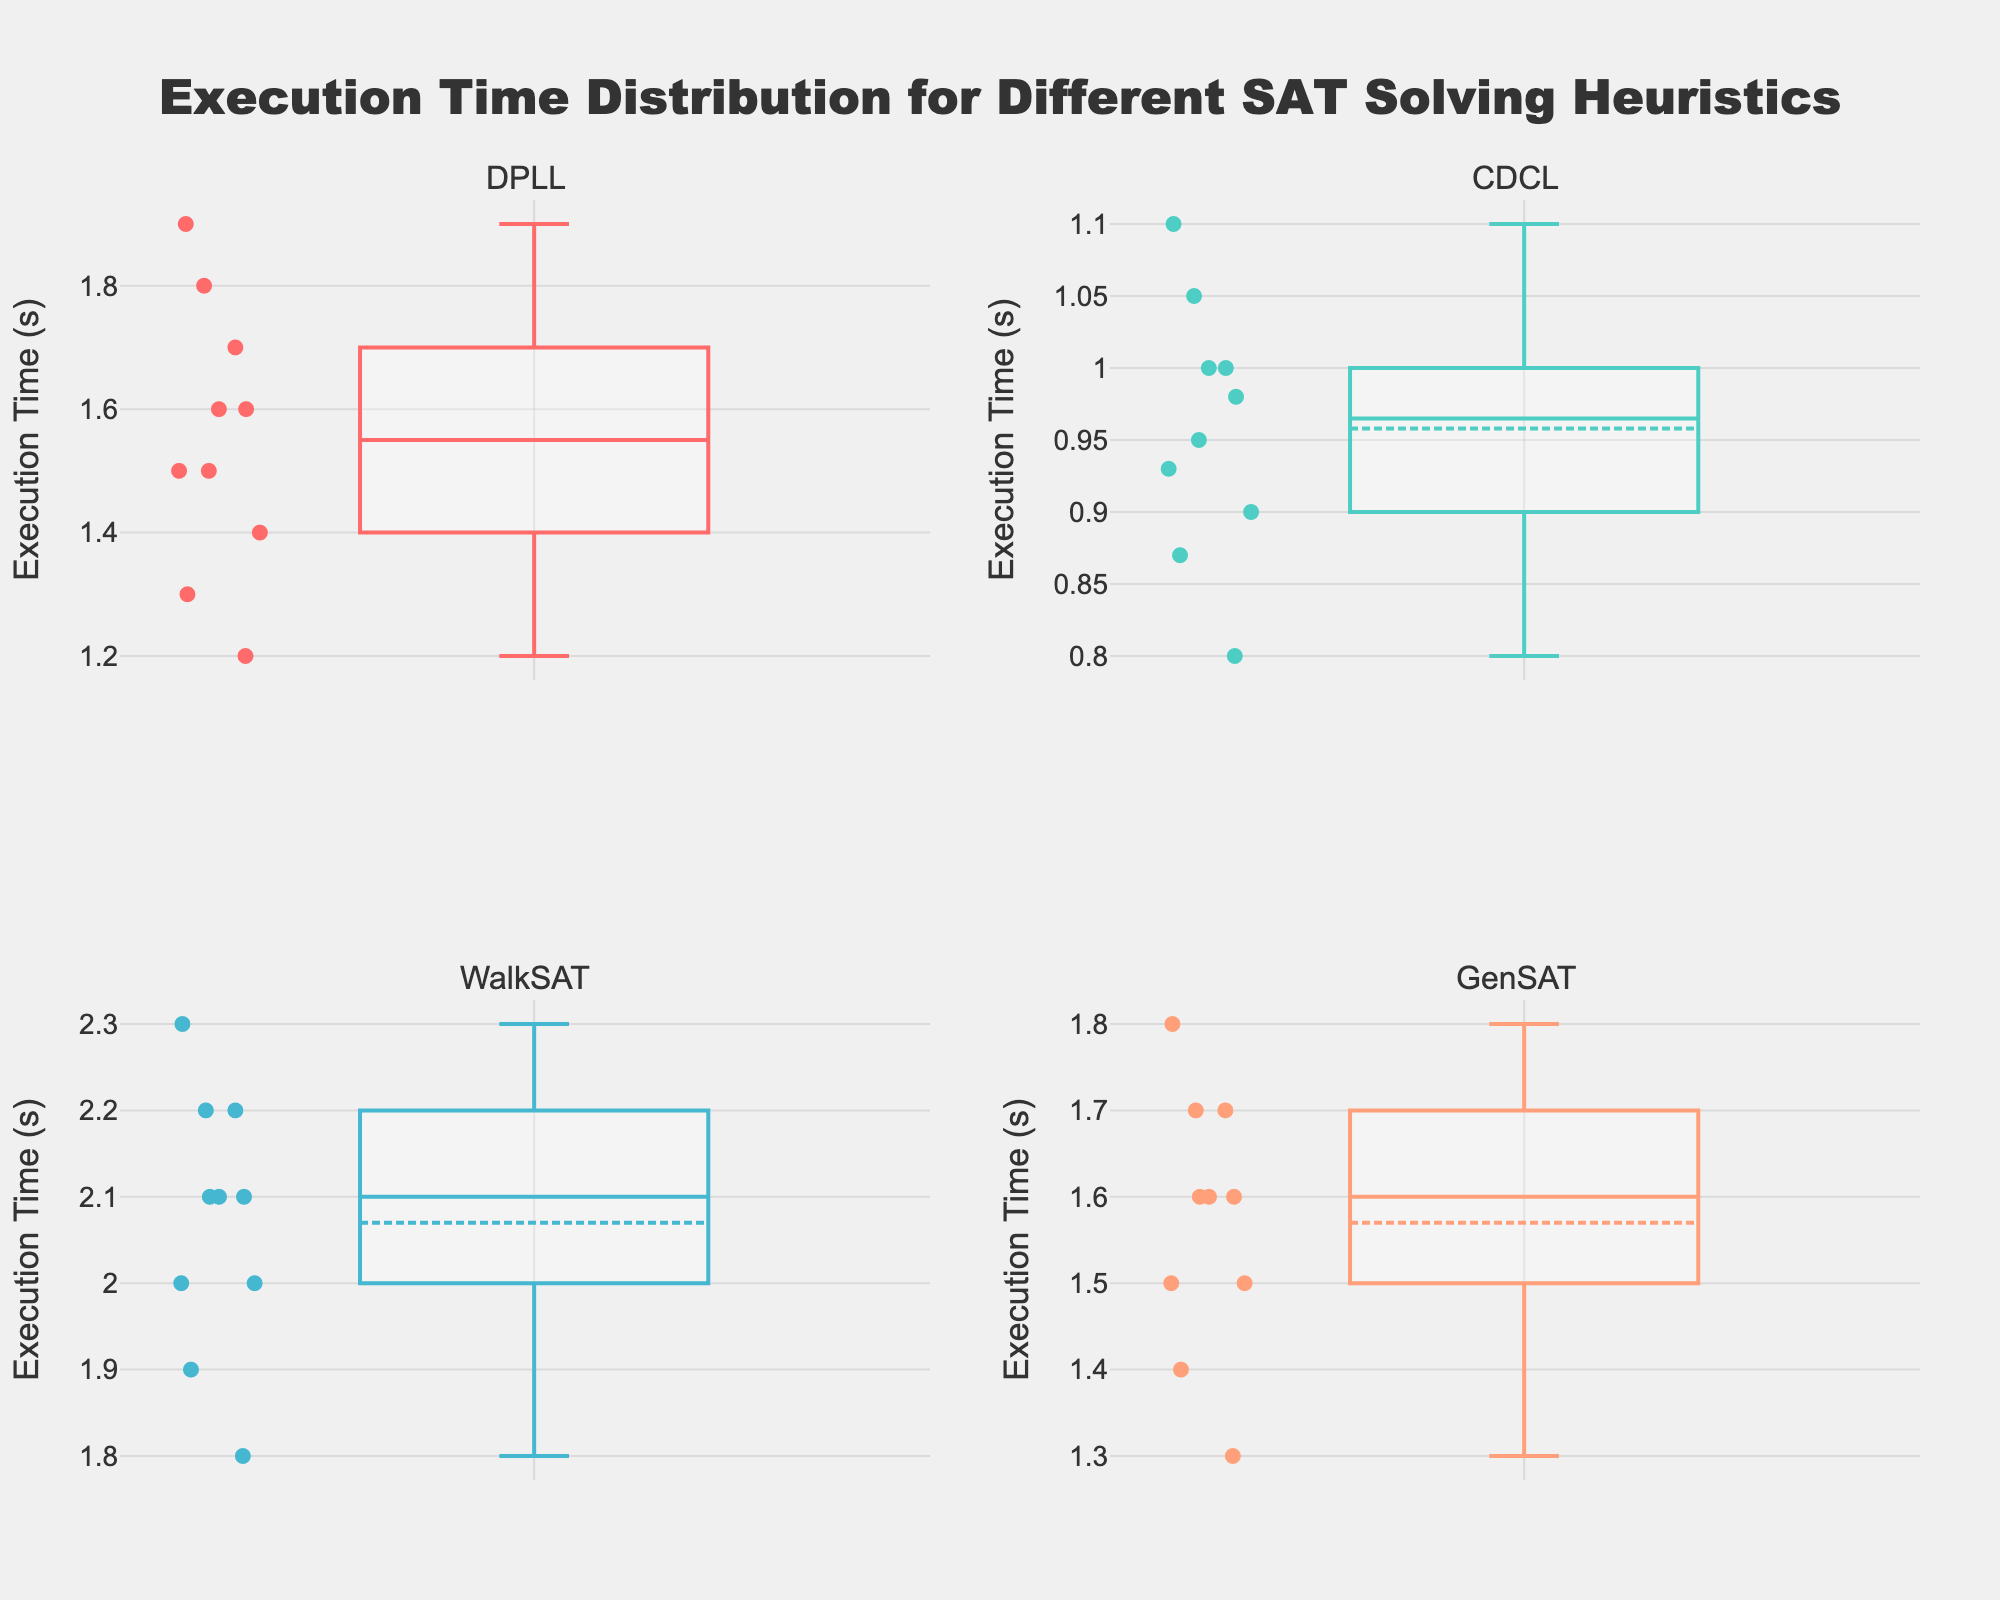What's the title of the figure? The title is typically displayed at the top of the figure. In this case, it's clearly written and centered.
Answer: Execution Time Distribution for Different SAT Solving Heuristics Which algorithm has the widest distribution of execution times? Looking at the spread of the data points and the length of the whiskers, WalkSAT has the widest distribution among the subplots.
Answer: WalkSAT What's the median execution time for CDCL? The median is represented by the line inside the box of the box plot. For CDCL, it is observed directly in the corresponding subplot.
Answer: 0.985 Which algorithm has the highest maximum execution time? The maximum value in each box plot is represented by the top whisker or outlier. WalkSAT's subplot shows the highest maximum value among all algorithms.
Answer: WalkSAT Compare the interquartile range (IQR) of DPLL and CDCL. Which one is larger? IQR is the range between the first (lower) quartile and the third (upper) quartile of the box plot. By visually comparing the lengths of the boxes, DPLL has a larger IQR.
Answer: DPLL What is the common execution time range for GenSAT? The common range is represented by the length of the box from the first quartile to the third quartile. For GenSAT, this range is from 1.5 to 1.7 seconds.
Answer: 1.5 to 1.7 seconds Which algorithms have overlapping ranges of common execution times (IQR)? By visually comparing the ranges of the boxes (IQR), both DPLL and GenSAT as well as CDCL and DPLL show overlapping ranges.
Answer: DPLL and GenSAT; CDCL and DPLL Which algorithm has the most consistent execution times with the smallest variability? The consistency can be evaluated by looking at the overall height (range) of the box plot. CDCL has the smallest range, indicating less variability.
Answer: CDCL In which algorithms do the data points include outliers? Outliers are represented by individual points outside the whiskers. By checking each subplot, no algorithm exhibits significant outliers since all points are well within the whiskers.
Answer: None What's the primary color used in the box plot for the WalkSAT algorithm? The primary color in a box plot can be identified by the color of the box and the points. For WalkSAT, it appears as a light blue or cyan in the figure.
Answer: Cyan 